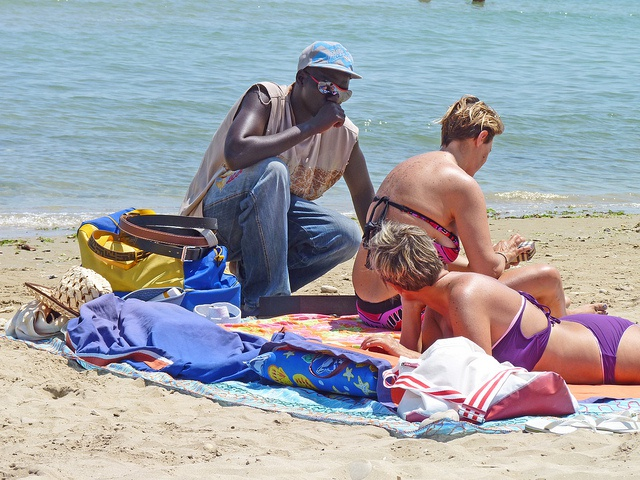Describe the objects in this image and their specific colors. I can see people in darkgray, gray, and black tones, people in darkgray, brown, tan, maroon, and purple tones, people in darkgray, brown, tan, black, and maroon tones, handbag in darkgray, white, and brown tones, and handbag in darkgray, blue, lightblue, and navy tones in this image. 